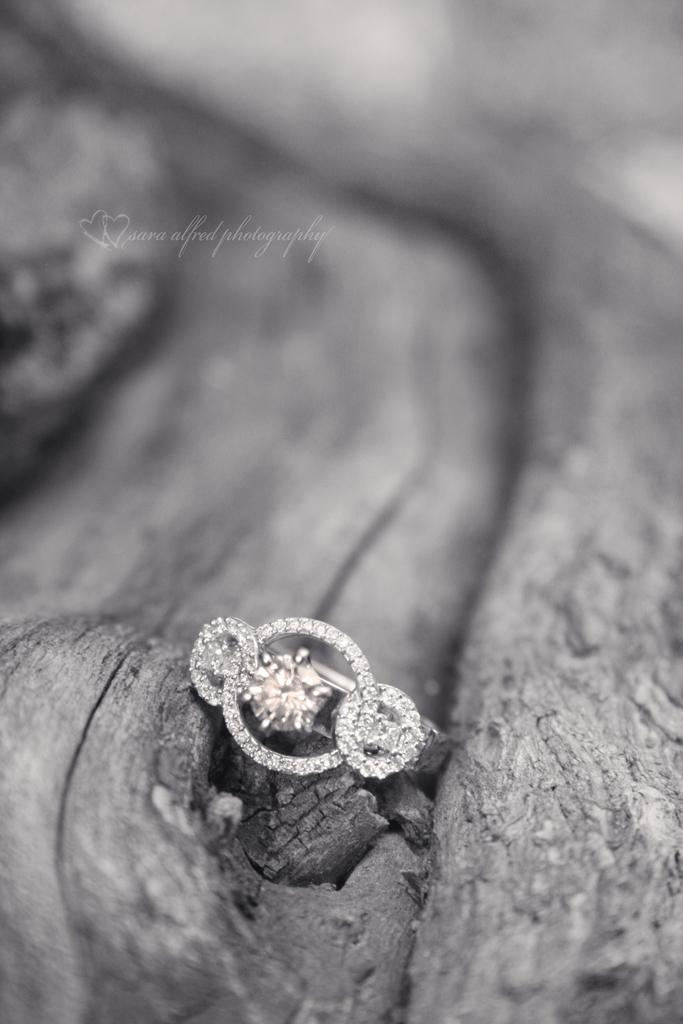What type of material is the main object in the image made of? The main object in the image is made of a wooden substance. What is placed on the wooden substance? There is a finger ring on the wooden substance. What is special about the finger ring? The finger ring is full of diamonds. What type of throne is the person sitting on in the image? There is no person or throne present in the image; it only features a wooden substance with a diamond-filled finger ring on it. 